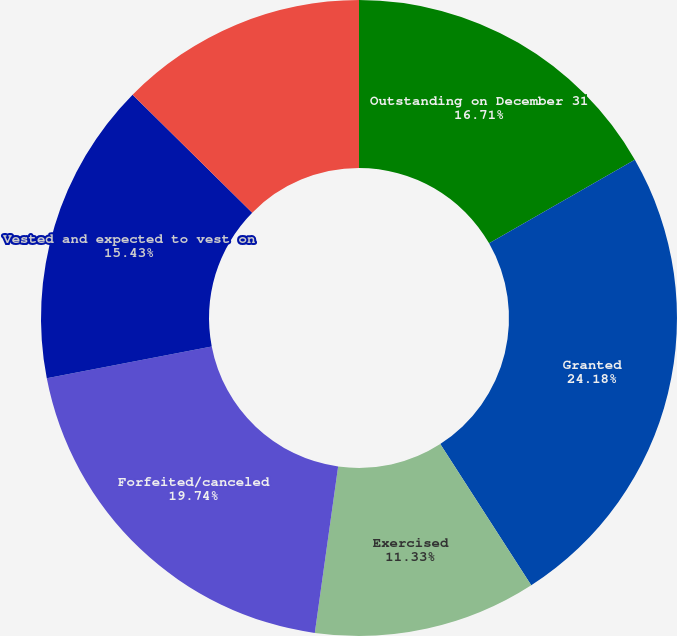Convert chart. <chart><loc_0><loc_0><loc_500><loc_500><pie_chart><fcel>Outstanding on December 31<fcel>Granted<fcel>Exercised<fcel>Forfeited/canceled<fcel>Vested and expected to vest on<fcel>Exercisable on December 31<nl><fcel>16.71%<fcel>24.18%<fcel>11.33%<fcel>19.74%<fcel>15.43%<fcel>12.61%<nl></chart> 